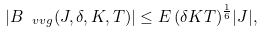Convert formula to latex. <formula><loc_0><loc_0><loc_500><loc_500>| B _ { \ v v g } ( J , \delta , K , T ) | \leq E \, ( \delta K T ) ^ { \frac { 1 } { 6 } } | J | ,</formula> 